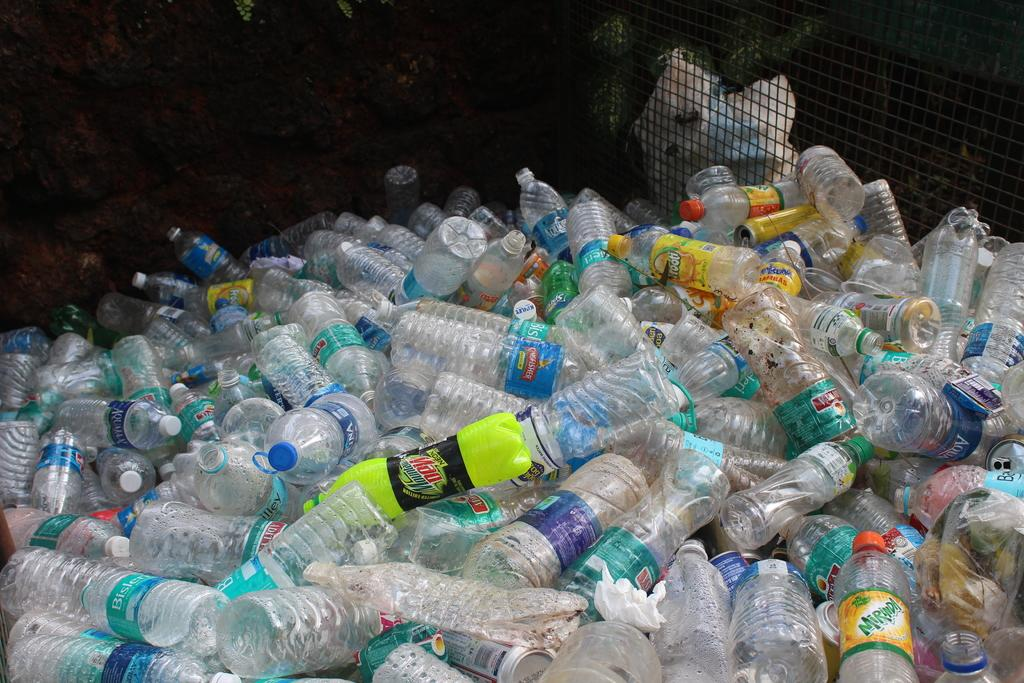<image>
Write a terse but informative summary of the picture. Lots of plastic bottles being recycled for example mountain dew. 